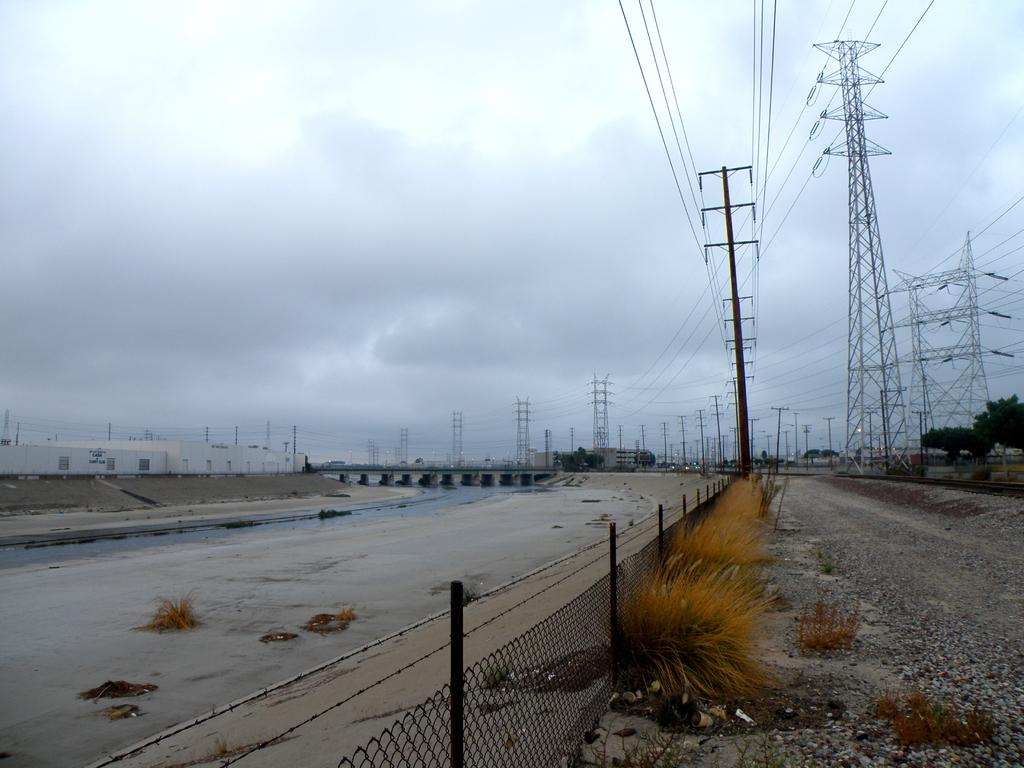What type of vegetation can be seen in the image? There is grass, plants, and trees visible in the image. What man-made structures can be seen in the image? There are cell towers, poles, a bridge, buildings, and a fence visible in the image. What natural element is visible in the image? Water is visible in the image. What part of the sky is visible in the image? The sky is visible in the image. How many payments are being made by the trees in the image? There are no payments being made by the trees in the image, as trees do not have the ability to make payments. What type of trousers are the plants wearing in the image? There are no trousers present in the image, as plants do not wear clothing. 